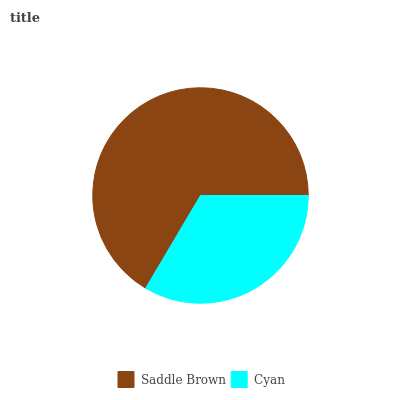Is Cyan the minimum?
Answer yes or no. Yes. Is Saddle Brown the maximum?
Answer yes or no. Yes. Is Cyan the maximum?
Answer yes or no. No. Is Saddle Brown greater than Cyan?
Answer yes or no. Yes. Is Cyan less than Saddle Brown?
Answer yes or no. Yes. Is Cyan greater than Saddle Brown?
Answer yes or no. No. Is Saddle Brown less than Cyan?
Answer yes or no. No. Is Saddle Brown the high median?
Answer yes or no. Yes. Is Cyan the low median?
Answer yes or no. Yes. Is Cyan the high median?
Answer yes or no. No. Is Saddle Brown the low median?
Answer yes or no. No. 